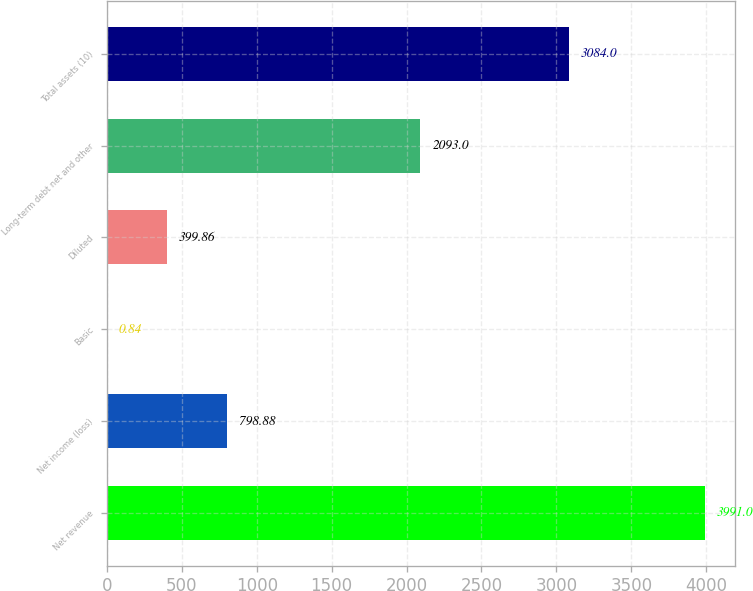Convert chart to OTSL. <chart><loc_0><loc_0><loc_500><loc_500><bar_chart><fcel>Net revenue<fcel>Net income (loss)<fcel>Basic<fcel>Diluted<fcel>Long-term debt net and other<fcel>Total assets (10)<nl><fcel>3991<fcel>798.88<fcel>0.84<fcel>399.86<fcel>2093<fcel>3084<nl></chart> 